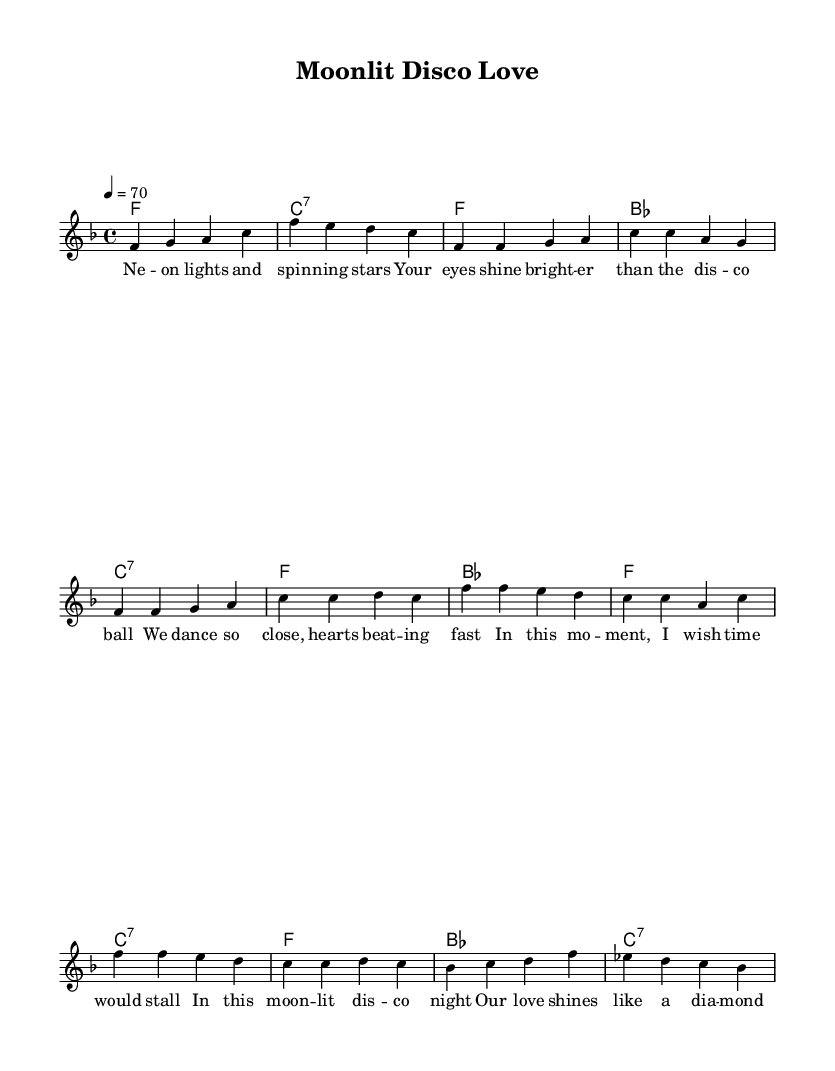What is the key signature of this music? The key signature is F major, indicated by one flat (B flat). In the music sheet, this is seen in the key signature section at the beginning.
Answer: F major What is the time signature of this music? The time signature is 4/4, which is represented at the start of the piece. This indicates four beats per measure, with a quarter note receiving one beat.
Answer: 4/4 What is the tempo marking of this music? The tempo marking is at 70 beats per minute, denoted with "4 = 70". This shows the intended speed of the piece.
Answer: 70 Which section contains the lyrics about romantic feelings? The chorus lyrics express romantic feelings, discussing love shining brightly in a disco night and the desire for closeness. They are featured after the verses.
Answer: Chorus How many measures are in the chorus section? The chorus consists of four measures, as indicated by the four lines of lyrics set to music in that section. Each line corresponds to one measure of music.
Answer: Four What is the first chord played in the intro? The first chord played in the intro is F major, indicated at the beginning of the harmonies section. This sets the tonality for the piece right from the start.
Answer: F What musical elements are typical of disco ballads in this piece? This piece features piano accompaniment, a romantic theme in the lyrics, and a danceable 4/4 time signature, which are all characteristic of disco ballads.
Answer: Piano, romantic lyrics 